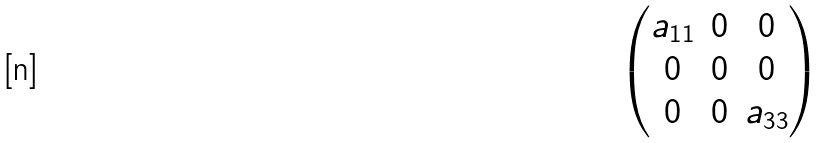Convert formula to latex. <formula><loc_0><loc_0><loc_500><loc_500>\begin{pmatrix} a _ { 1 1 } & 0 & 0 \\ 0 & 0 & 0 \\ 0 & 0 & a _ { 3 3 } \\ \end{pmatrix}</formula> 